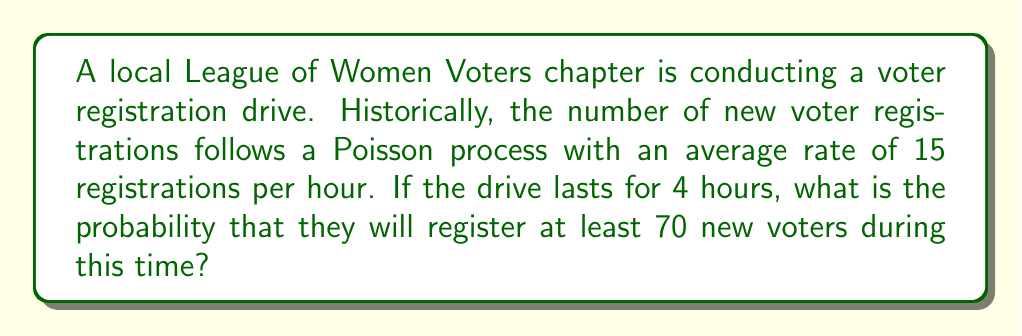What is the answer to this math problem? Let's approach this step-by-step:

1) We are dealing with a Poisson process where:
   - The rate (λ) is 15 registrations per hour
   - The time period (t) is 4 hours

2) For a Poisson process, the number of events in a time interval of length t follows a Poisson distribution with mean λt.

3) In this case, the mean number of registrations in 4 hours is:
   $$\mu = \lambda t = 15 \cdot 4 = 60$$

4) We want to find P(X ≥ 70), where X is the number of registrations.

5) This is equivalent to 1 - P(X < 70) = 1 - P(X ≤ 69)

6) The cumulative distribution function of a Poisson distribution is given by:
   $$P(X \leq k) = e^{-\mu} \sum_{i=0}^k \frac{\mu^i}{i!}$$

7) Therefore, we need to calculate:
   $$1 - P(X \leq 69) = 1 - e^{-60} \sum_{i=0}^{69} \frac{60^i}{i!}$$

8) This calculation is complex to do by hand, so we would typically use statistical software or tables. Using such tools, we find:

   $$P(X \geq 70) \approx 0.1056$$

This means there is approximately a 10.56% chance of registering at least 70 new voters during the 4-hour drive.
Answer: 0.1056 